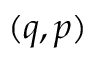Convert formula to latex. <formula><loc_0><loc_0><loc_500><loc_500>( q , p )</formula> 